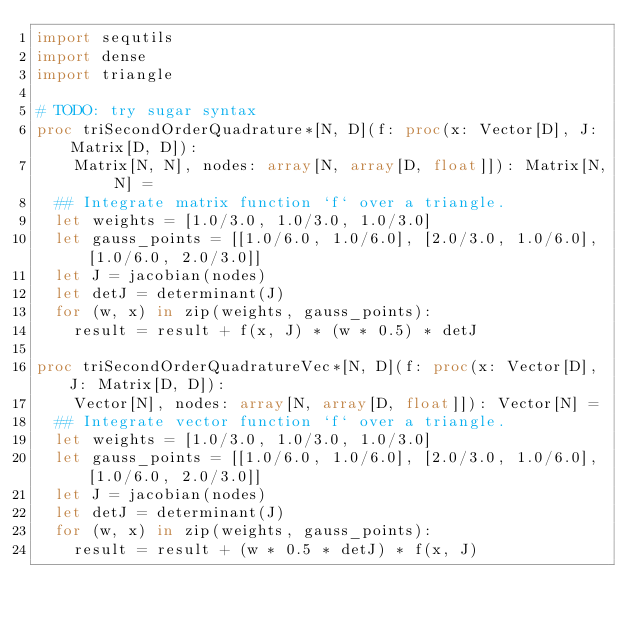<code> <loc_0><loc_0><loc_500><loc_500><_Nim_>import sequtils
import dense
import triangle

# TODO: try sugar syntax
proc triSecondOrderQuadrature*[N, D](f: proc(x: Vector[D], J: Matrix[D, D]):
    Matrix[N, N], nodes: array[N, array[D, float]]): Matrix[N, N] =
  ## Integrate matrix function `f` over a triangle.
  let weights = [1.0/3.0, 1.0/3.0, 1.0/3.0]
  let gauss_points = [[1.0/6.0, 1.0/6.0], [2.0/3.0, 1.0/6.0], [1.0/6.0, 2.0/3.0]]
  let J = jacobian(nodes)
  let detJ = determinant(J)
  for (w, x) in zip(weights, gauss_points):
    result = result + f(x, J) * (w * 0.5) * detJ

proc triSecondOrderQuadratureVec*[N, D](f: proc(x: Vector[D], J: Matrix[D, D]):
    Vector[N], nodes: array[N, array[D, float]]): Vector[N] =
  ## Integrate vector function `f` over a triangle.
  let weights = [1.0/3.0, 1.0/3.0, 1.0/3.0]
  let gauss_points = [[1.0/6.0, 1.0/6.0], [2.0/3.0, 1.0/6.0], [1.0/6.0, 2.0/3.0]]
  let J = jacobian(nodes)
  let detJ = determinant(J)
  for (w, x) in zip(weights, gauss_points):
    result = result + (w * 0.5 * detJ) * f(x, J)
</code> 